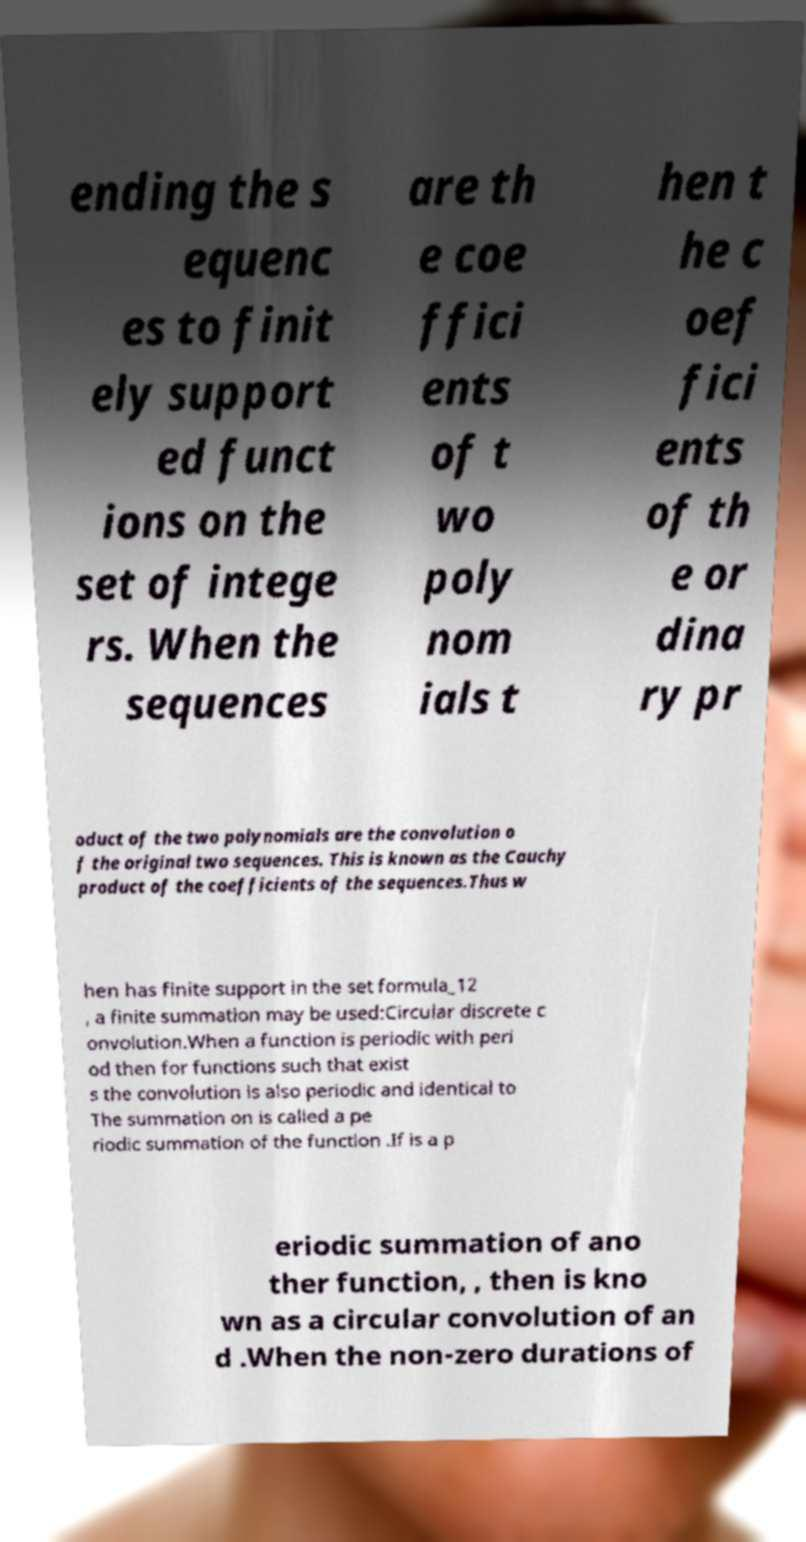Could you assist in decoding the text presented in this image and type it out clearly? ending the s equenc es to finit ely support ed funct ions on the set of intege rs. When the sequences are th e coe ffici ents of t wo poly nom ials t hen t he c oef fici ents of th e or dina ry pr oduct of the two polynomials are the convolution o f the original two sequences. This is known as the Cauchy product of the coefficients of the sequences.Thus w hen has finite support in the set formula_12 , a finite summation may be used:Circular discrete c onvolution.When a function is periodic with peri od then for functions such that exist s the convolution is also periodic and identical to The summation on is called a pe riodic summation of the function .If is a p eriodic summation of ano ther function, , then is kno wn as a circular convolution of an d .When the non-zero durations of 